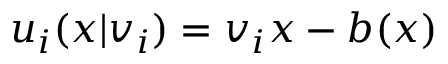Convert formula to latex. <formula><loc_0><loc_0><loc_500><loc_500>u _ { i } ( x | v _ { i } ) = v _ { i } x - b ( x )</formula> 